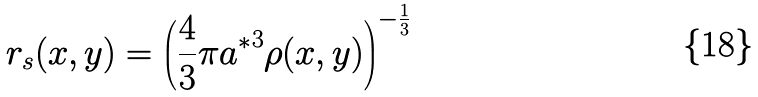Convert formula to latex. <formula><loc_0><loc_0><loc_500><loc_500>r _ { s } ( x , y ) = \left ( \frac { 4 } { 3 } \pi { a ^ { * } } ^ { 3 } \rho ( x , y ) \right ) ^ { - \frac { 1 } { 3 } }</formula> 